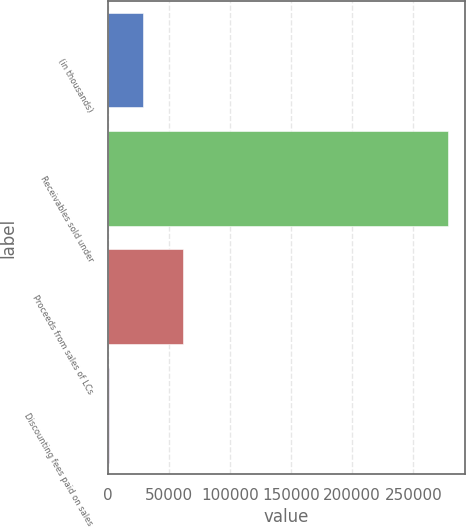Convert chart to OTSL. <chart><loc_0><loc_0><loc_500><loc_500><bar_chart><fcel>(in thousands)<fcel>Receivables sold under<fcel>Proceeds from sales of LCs<fcel>Discounting fees paid on sales<nl><fcel>28579.6<fcel>278560<fcel>61850<fcel>804<nl></chart> 